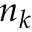<formula> <loc_0><loc_0><loc_500><loc_500>n _ { k }</formula> 